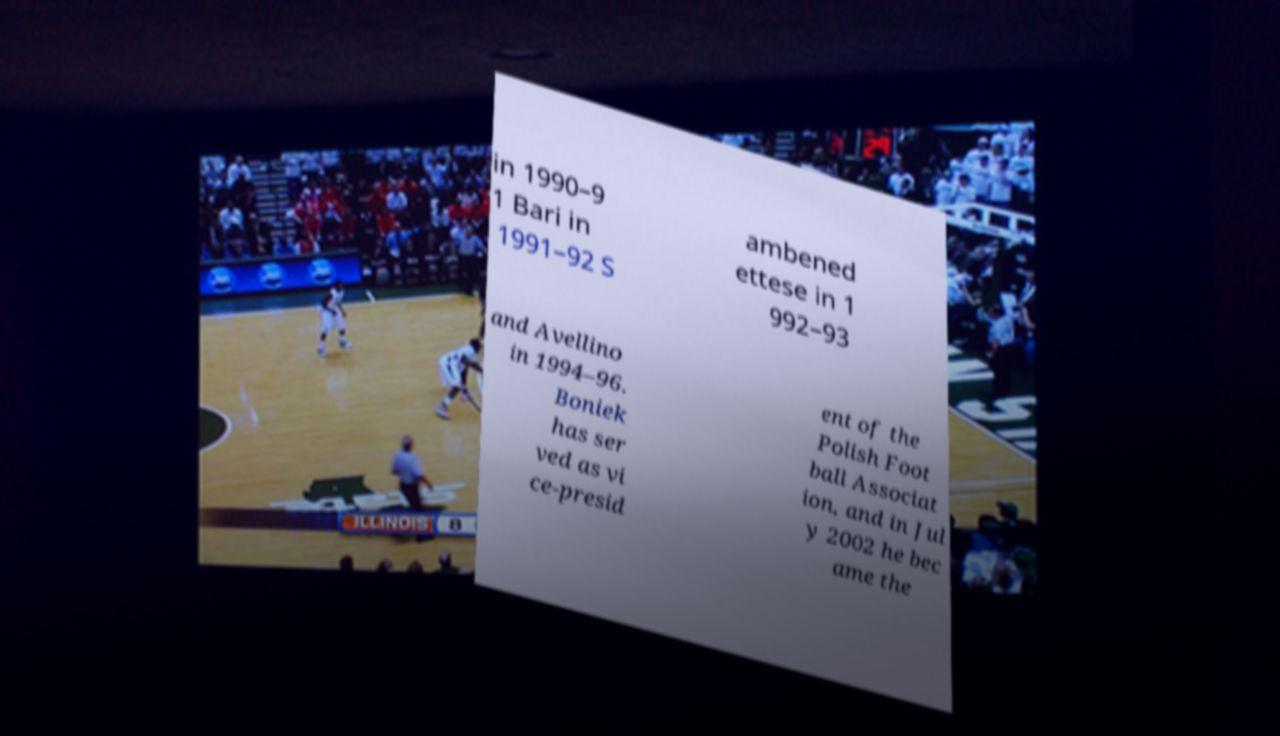There's text embedded in this image that I need extracted. Can you transcribe it verbatim? in 1990–9 1 Bari in 1991–92 S ambened ettese in 1 992–93 and Avellino in 1994–96. Boniek has ser ved as vi ce-presid ent of the Polish Foot ball Associat ion, and in Jul y 2002 he bec ame the 